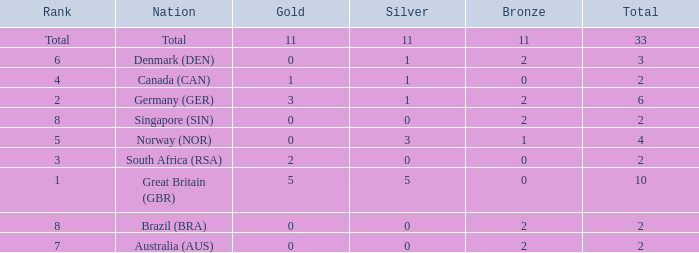Help me parse the entirety of this table. {'header': ['Rank', 'Nation', 'Gold', 'Silver', 'Bronze', 'Total'], 'rows': [['Total', 'Total', '11', '11', '11', '33'], ['6', 'Denmark (DEN)', '0', '1', '2', '3'], ['4', 'Canada (CAN)', '1', '1', '0', '2'], ['2', 'Germany (GER)', '3', '1', '2', '6'], ['8', 'Singapore (SIN)', '0', '0', '2', '2'], ['5', 'Norway (NOR)', '0', '3', '1', '4'], ['3', 'South Africa (RSA)', '2', '0', '0', '2'], ['1', 'Great Britain (GBR)', '5', '5', '0', '10'], ['8', 'Brazil (BRA)', '0', '0', '2', '2'], ['7', 'Australia (AUS)', '0', '0', '2', '2']]} What is the least total when the nation is canada (can) and bronze is less than 0? None. 